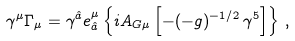Convert formula to latex. <formula><loc_0><loc_0><loc_500><loc_500>\gamma ^ { \mu } \Gamma _ { \mu } = \gamma ^ { \hat { a } } e ^ { \mu } _ { \hat { a } } \left \{ i A _ { G \mu } \left [ - ( - g ) ^ { - 1 / 2 } \, \gamma ^ { 5 } \right ] \right \} \, ,</formula> 